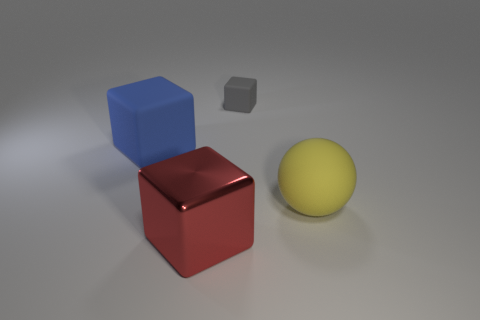What can you tell me about the colors of the objects? The image features objects with distinct colors: a blue cube, a red cube, and a yellow sphere. These primary colors could represent basic building blocks that combine to create a broad spectrum of colors, much like color theory in art and design. 